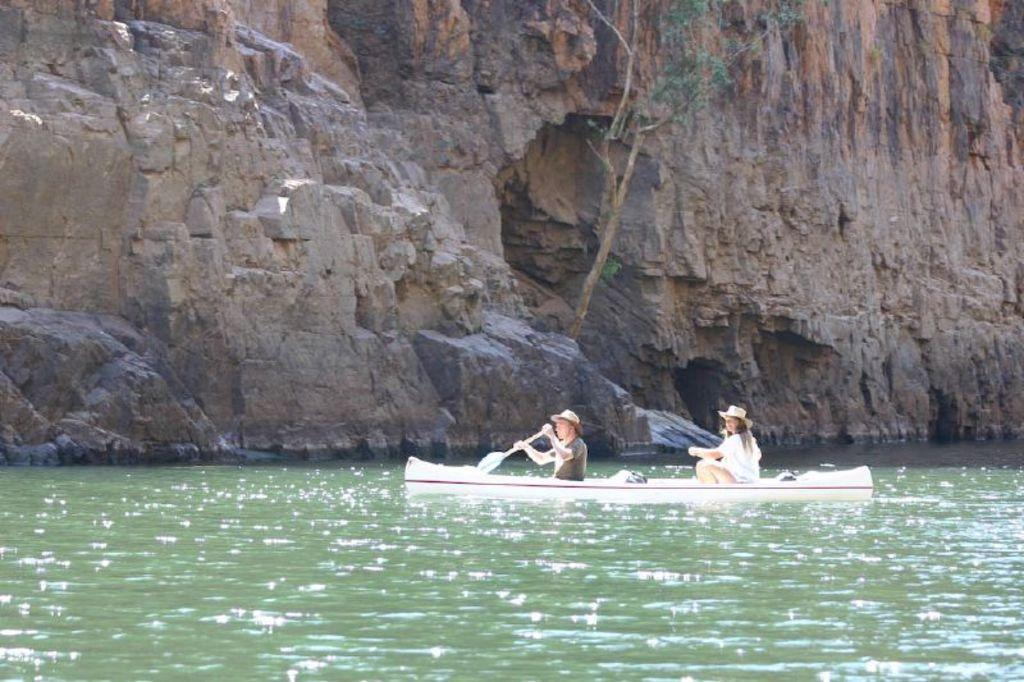What is the main object in the image? There is a rock in the image. Who or what else is present in the image? There are two people in the image. What are the people doing in the image? The people are sitting in a boat. What are the people holding in the image? The people are holding paddles. Where is the boat located in the image? The boat is on the water surface. How many ants can be seen crawling on the rock in the image? There are no ants present on the rock in the image. In which direction are the people paddling the boat? The image does not provide information about the direction in which the people are paddling the boat. 